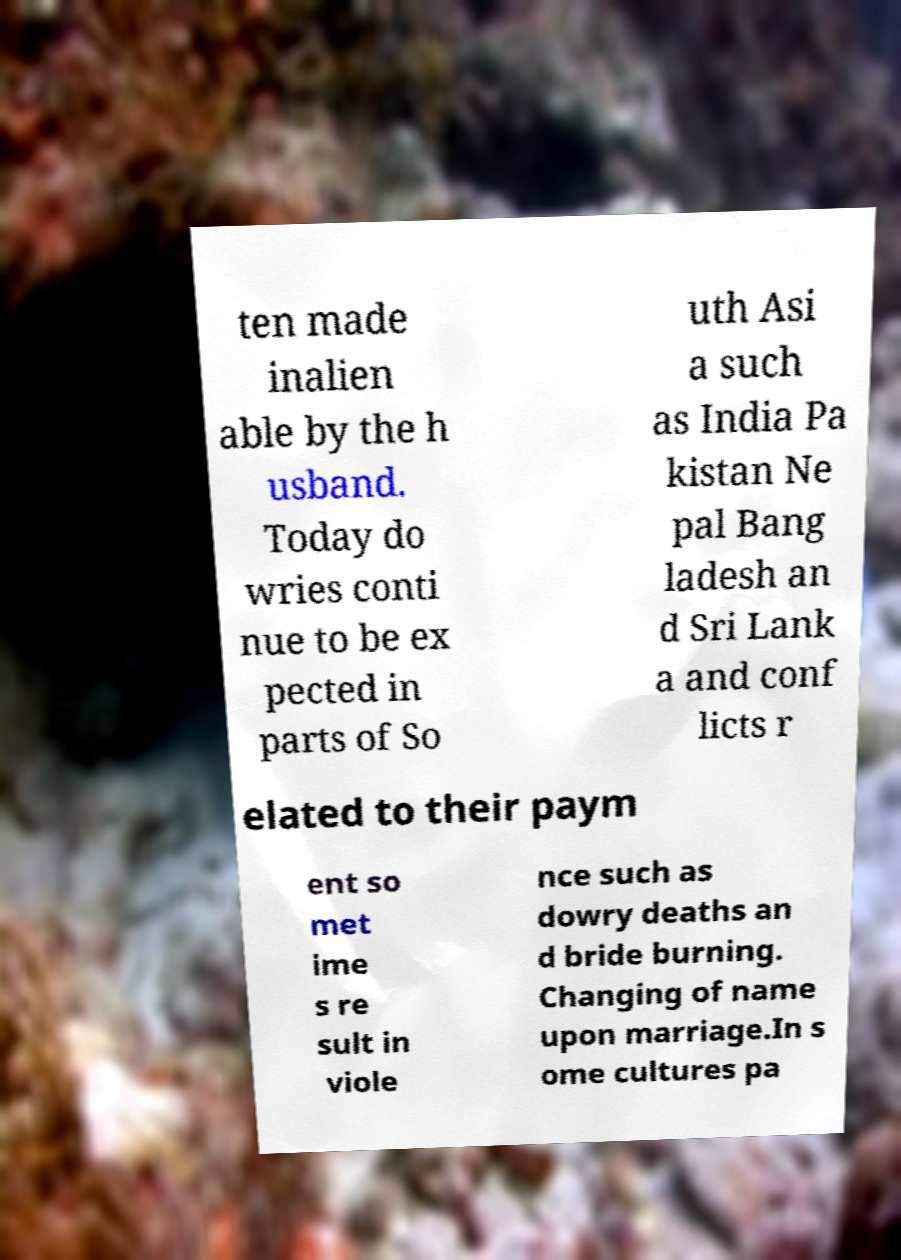Please read and relay the text visible in this image. What does it say? ten made inalien able by the h usband. Today do wries conti nue to be ex pected in parts of So uth Asi a such as India Pa kistan Ne pal Bang ladesh an d Sri Lank a and conf licts r elated to their paym ent so met ime s re sult in viole nce such as dowry deaths an d bride burning. Changing of name upon marriage.In s ome cultures pa 